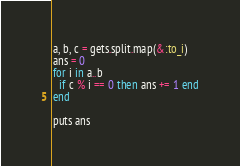<code> <loc_0><loc_0><loc_500><loc_500><_Ruby_>a, b, c = gets.split.map(&:to_i)
ans = 0
for i in a..b
  if c % i == 0 then ans += 1 end
end

puts ans
</code> 